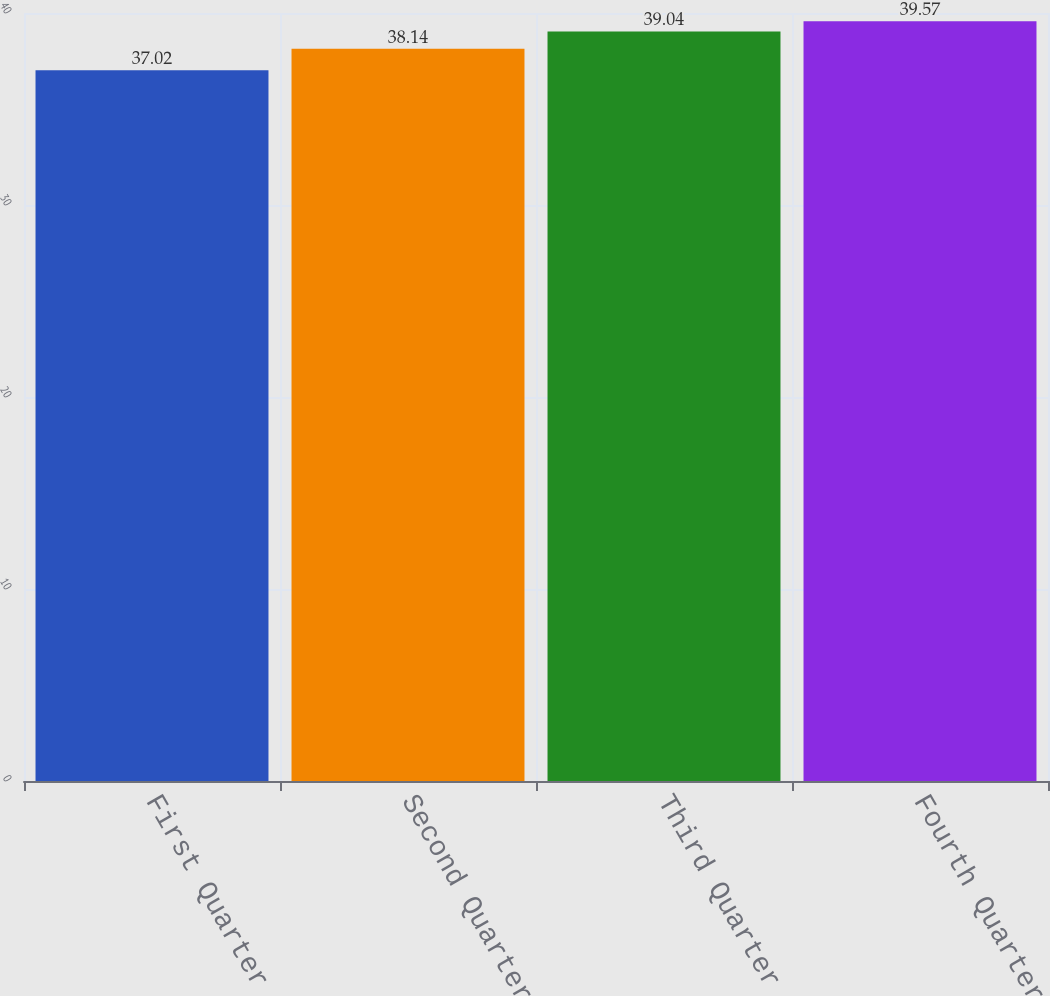<chart> <loc_0><loc_0><loc_500><loc_500><bar_chart><fcel>First Quarter<fcel>Second Quarter<fcel>Third Quarter<fcel>Fourth Quarter<nl><fcel>37.02<fcel>38.14<fcel>39.04<fcel>39.57<nl></chart> 